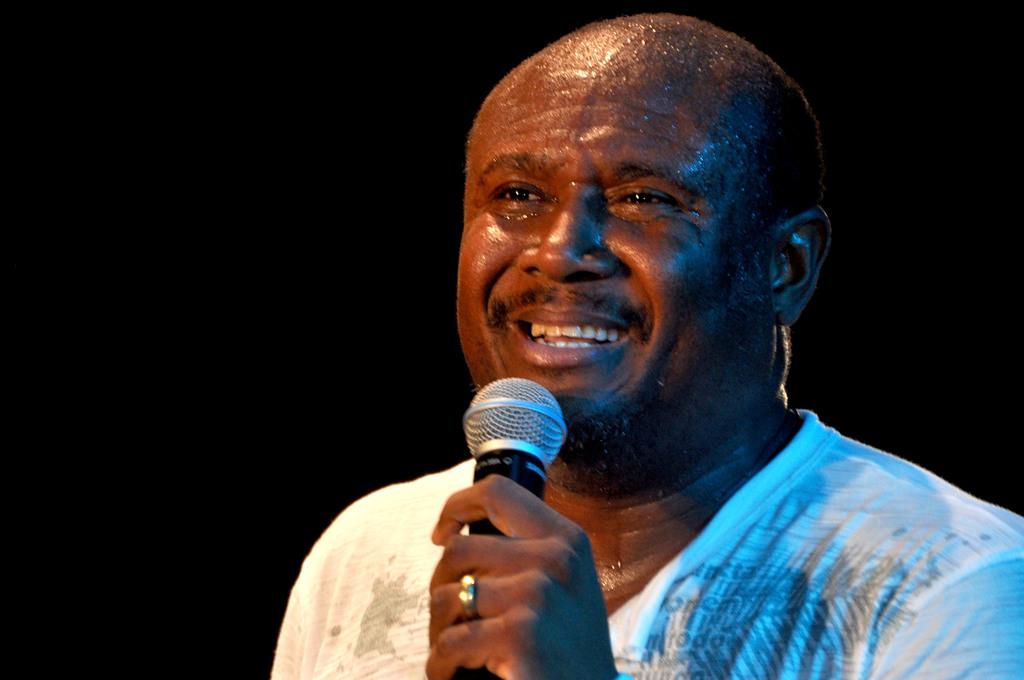What is the main subject of the image? There is a human in the image. What is the human doing in the image? The human is smiling and holding a microphone. Can you describe any accessories the human is wearing? The human is wearing a ring on his finger. What type of ornament is hanging from the microphone in the image? There is no ornament hanging from the microphone in the image. Can you describe the pancake that the human is holding in the image? There is no pancake present in the image; the human is holding a microphone. 